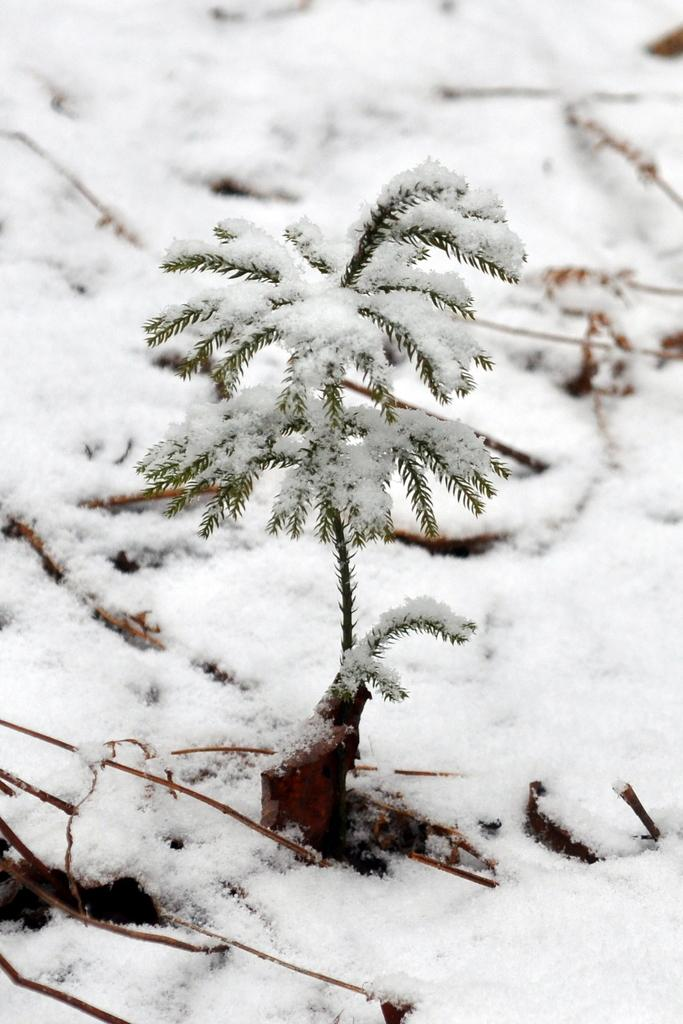What is the main subject in the center of the image? There is a small plant in the center of the image. What is the surrounding environment like in the image? There is snow around the area of the image. How much money is needed to purchase the pin in the image? There is no pin present in the image, so it is not possible to determine how much money would be needed to purchase one. 